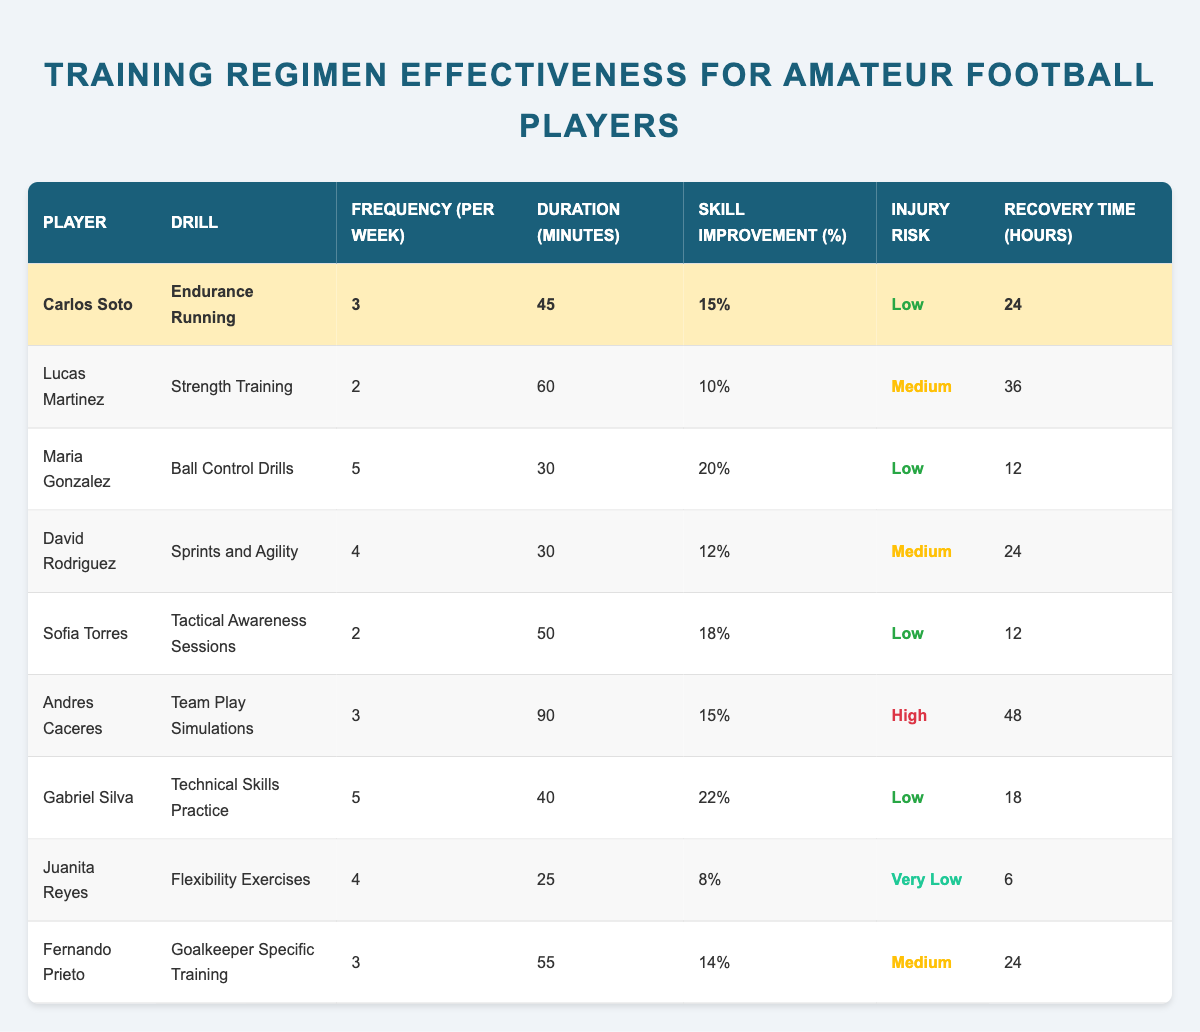What is the skill improvement percentage for Carlos Soto? According to the table, Carlos Soto has a skill improvement percentage of 15%. This can be found directly in the row corresponding to Carlos Soto.
Answer: 15% How many drills does Maria Gonzalez perform per week? Referring to the table, Maria Gonzalez performs her drills 5 times per week, which is listed in the corresponding row.
Answer: 5 Which player has the highest skill improvement percentage? By examining the skill improvement percentages in the table, Gabriel Silva has the highest percentage at 22%. This is found in the row for Gabriel Silva.
Answer: 22% What is the average recovery time for all players listed? To find the average recovery time, first, sum the recovery times: 24 + 36 + 12 + 24 + 12 + 48 + 18 + 6 + 24 = 204. There are 9 players, so the average is 204/9, which equals approximately 22.67 hours.
Answer: 22.67 Is the injury risk for Juanita Reyes categorized as low? In the table, Juanita Reyes' injury risk is listed as "Very Low," indicating that it is not categorized as low. Therefore, the answer is false based on the visual information provided.
Answer: No Which drill has the longest duration per session? According to the table, the "Team Play Simulations" drill has the longest duration at 90 minutes, as indicated in the row for Andres Caceres.
Answer: 90 How many players practice their drills more than 3 times per week? Analyzing the frequency of drills, the players practicing more than 3 times per week are Maria Gonzalez (5 times), David Rodriguez (4 times), and Gabriel Silva (5 times). This gives a total of 3 players in this category.
Answer: 3 Does Fernando Prieto have a higher injury risk compared to Sofia Torres? In the table, Fernando Prieto's injury risk is categorized as "Medium," while Sofia Torres' injury risk is "Low." Since medium is indeed higher than low, the answer is yes.
Answer: Yes What is the frequency difference in training sessions between the player with the highest and lowest frequency? Maria Gonzalez trains 5 times a week while Juanita Reyes trains 4 times a week. The difference is 5 - 4 = 1. Therefore, the frequency difference in training sessions is 1.
Answer: 1 